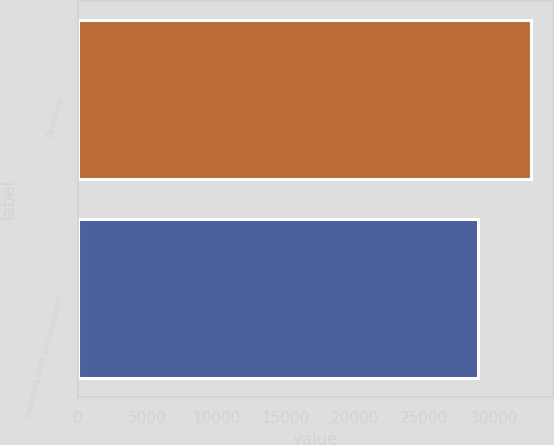Convert chart to OTSL. <chart><loc_0><loc_0><loc_500><loc_500><bar_chart><fcel>Revenues<fcel>Operating costs and expenses<nl><fcel>32677<fcel>28851<nl></chart> 